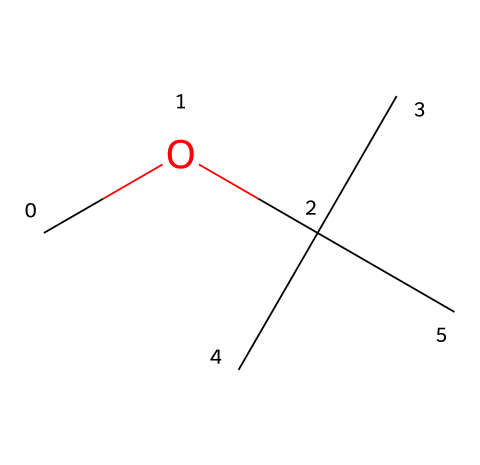What is the name of the chemical represented by this structure? The SMILES representation "COC(C)(C)C" corresponds to methyl tert-butyl ether, which is a common gasoline additive.
Answer: methyl tert-butyl ether How many carbon atoms are present in the structure? By analyzing the SMILES string, there are five carbon atoms represented: one in the methyl group and four in the tert-butyl group.
Answer: five What functional group is present in this chemical? The presence of the ether linkage (C-O-C) indicates that the functional group in this chemical is an ether.
Answer: ether What type of isomerism can be observed in methyl tert-butyl ether? The molecule can exhibit chain isomerism since it features branching in its carbon structure (the tert-butyl group).
Answer: chain isomerism What is the degree of branching in this chemical structure? The tert-butyl group has three equivalent methyl groups connected to a central carbon, indicating a high degree of branching in the structure.
Answer: high How many hydrogen atoms are bonded to the carbon atoms in this molecule? Within the structure, the five carbon atoms can be counted along with the hydrogens bonded: the total hydrogen accounts to 12 (three methyl groups, one from the methyl carbon, and two from the tert-butyl carbon).
Answer: twelve 